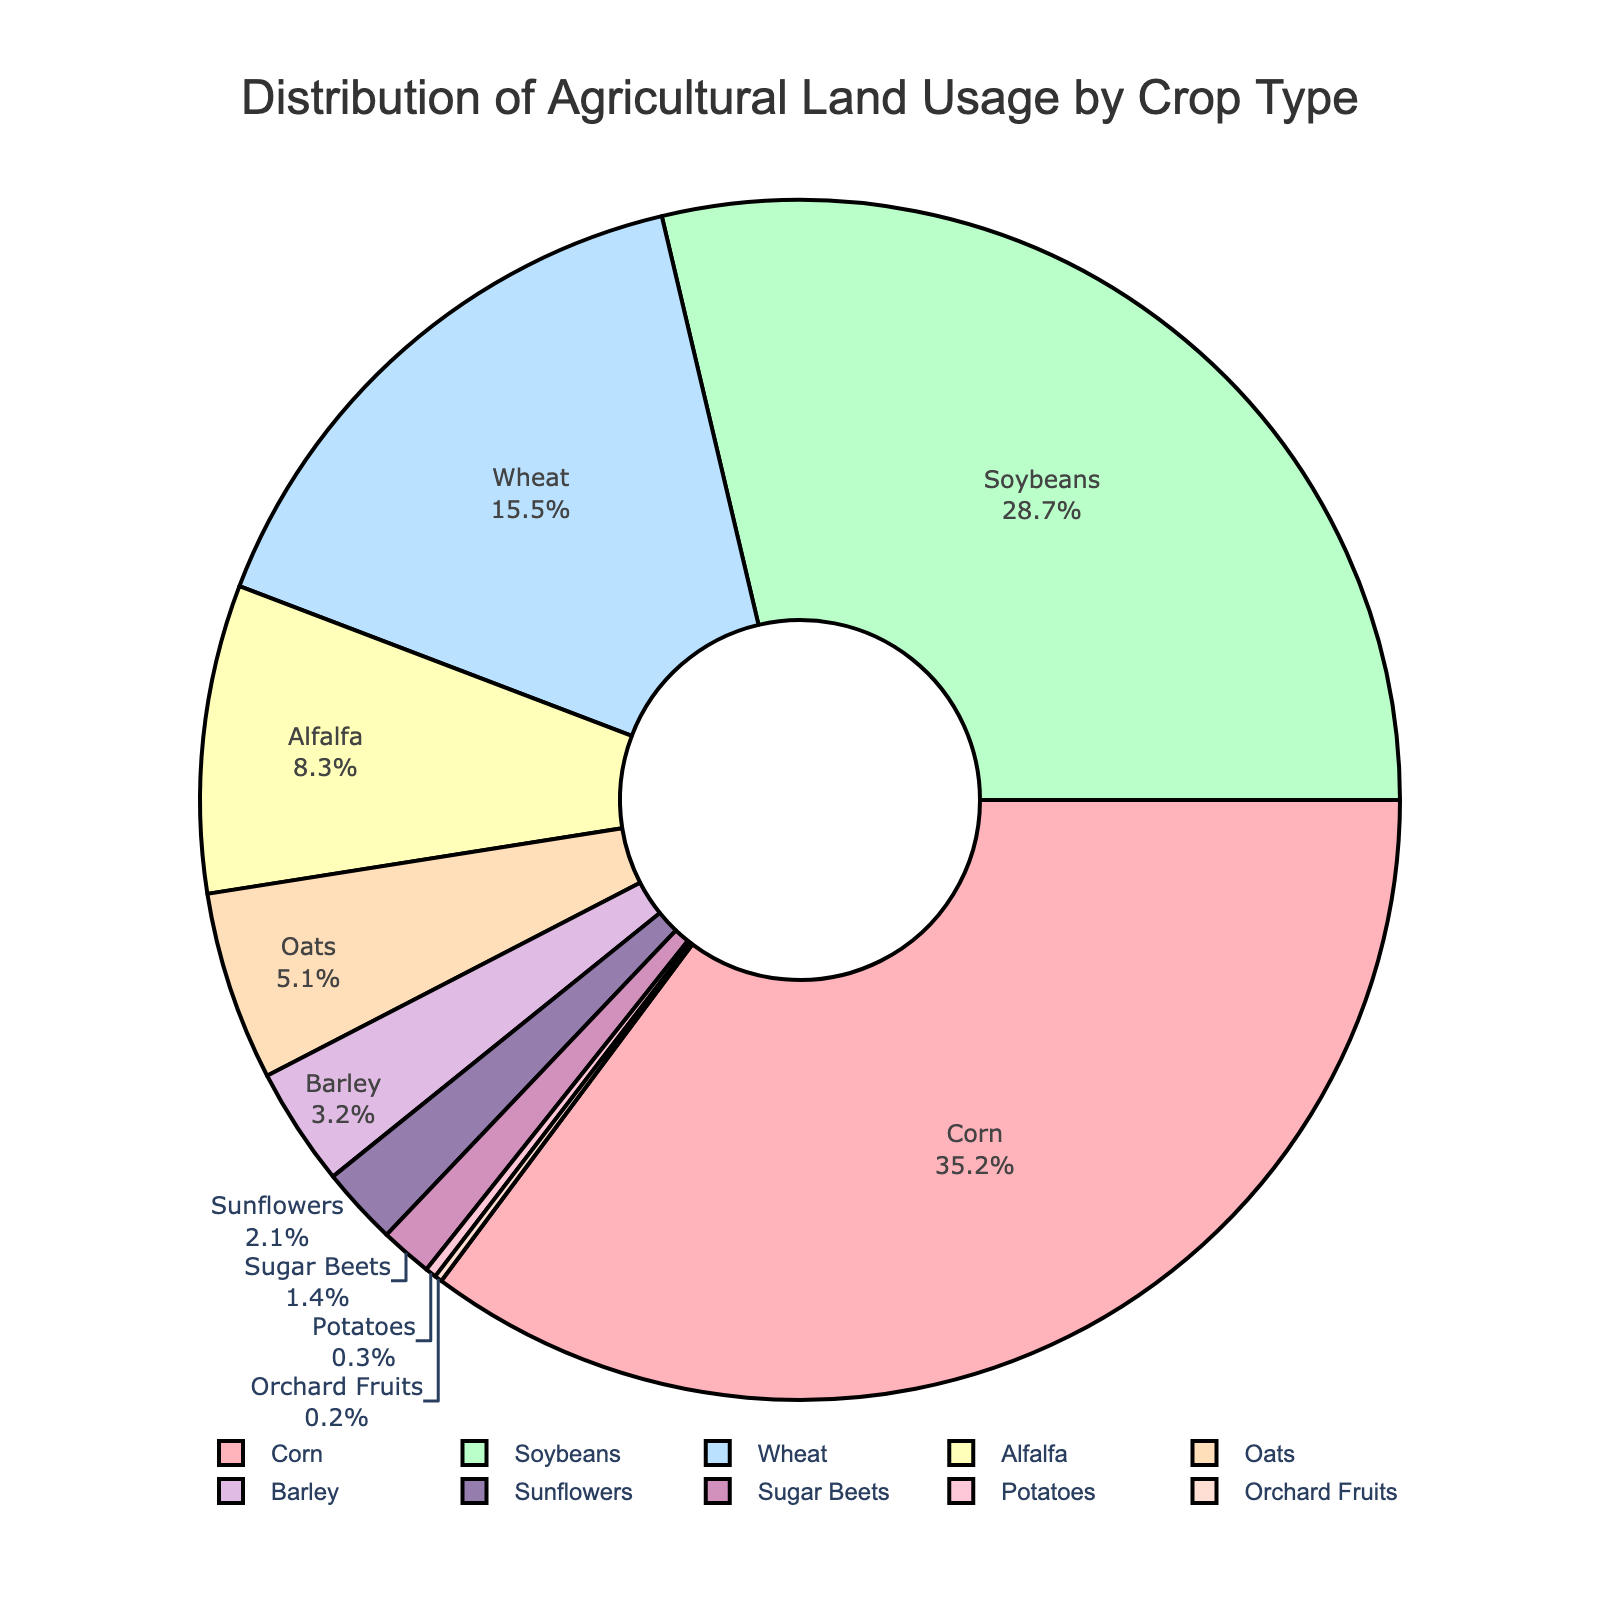What's the largest crop type in terms of land usage? The largest segment in the pie chart represents Corn, and its percentage is 35.2%.
Answer: Corn Which two crop types combined use the most land? Combining the percentages for Corn (35.2%) and Soybeans (28.7%), they together use the most land (35.2 + 28.7 = 63.9%).
Answer: Corn and Soybeans How much more land is used for growing Corn than Sunflowers? Subtract the percentage for Sunflowers (2.1%) from the percentage for Corn (35.2%), which results in a difference of 33.1%.
Answer: 33.1% What fraction of the agricultural land is used for growing wheat? Wheat uses 15.5% of the agricultural land, which can be expressed as a fraction of 15.5/100.
Answer: 15.5/100 Is the land used for growing Barley greater than the land used for growing Alfalfa? The percentage for Barley (3.2%) is less than that for Alfalfa (8.3%). Therefore, Barley uses less land than Alfalfa.
Answer: No What is the total percentage of land used for growing less common crops (below 5%)? Adding the percentages for Oats (5.1%), Barley (3.2%), Sunflowers (2.1%), Sugar Beets (1.4%), Potatoes (0.3%), Orchard Fruits (0.2%), we get 5.1 + 3.2 + 2.1 + 1.4 + 0.3 + 0.2 = 12.3%.
Answer: 12.3% Which crop type uses the smallest portion of the agricultural land? The smallest segment in the pie chart represents Orchard Fruits, and its percentage is 0.2%.
Answer: Orchard Fruits By how much does the percentage of land used for growing Alfalfa differ from the percentage for Wheat? Subtract the percentage for Alfalfa (8.3%) from the percentage for Wheat (15.5%), which results in a difference of 7.2%.
Answer: 7.2% What is the average percentage land usage for Corn, Soybeans, and Wheat? Sum the percentages for Corn (35.2%), Soybeans (28.7%), and Wheat (15.5%) which equals 79.4%. Then divide by 3 to get 79.4/3 = 26.47%.
Answer: 26.47% 